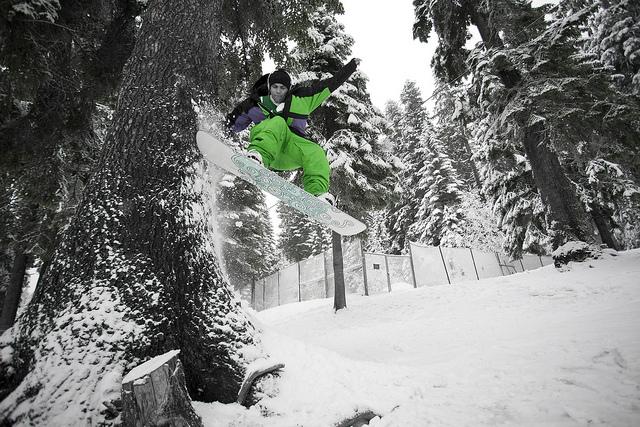Can you see any grass?
Concise answer only. No. How many trees are visible in the image?
Short answer required. 6. Is it snowing?
Quick response, please. No. What is the man doing?
Be succinct. Snowboarding. Is this man wearing skis?
Concise answer only. No. If this image were in all natural color, what color would the leaves of the trees be?
Short answer required. Green. 